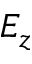Convert formula to latex. <formula><loc_0><loc_0><loc_500><loc_500>E _ { z }</formula> 